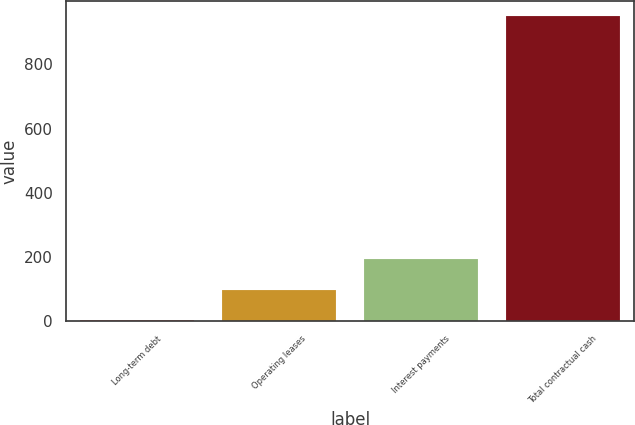Convert chart. <chart><loc_0><loc_0><loc_500><loc_500><bar_chart><fcel>Long-term debt<fcel>Operating leases<fcel>Interest payments<fcel>Total contractual cash<nl><fcel>2.9<fcel>97.7<fcel>192.5<fcel>950.9<nl></chart> 